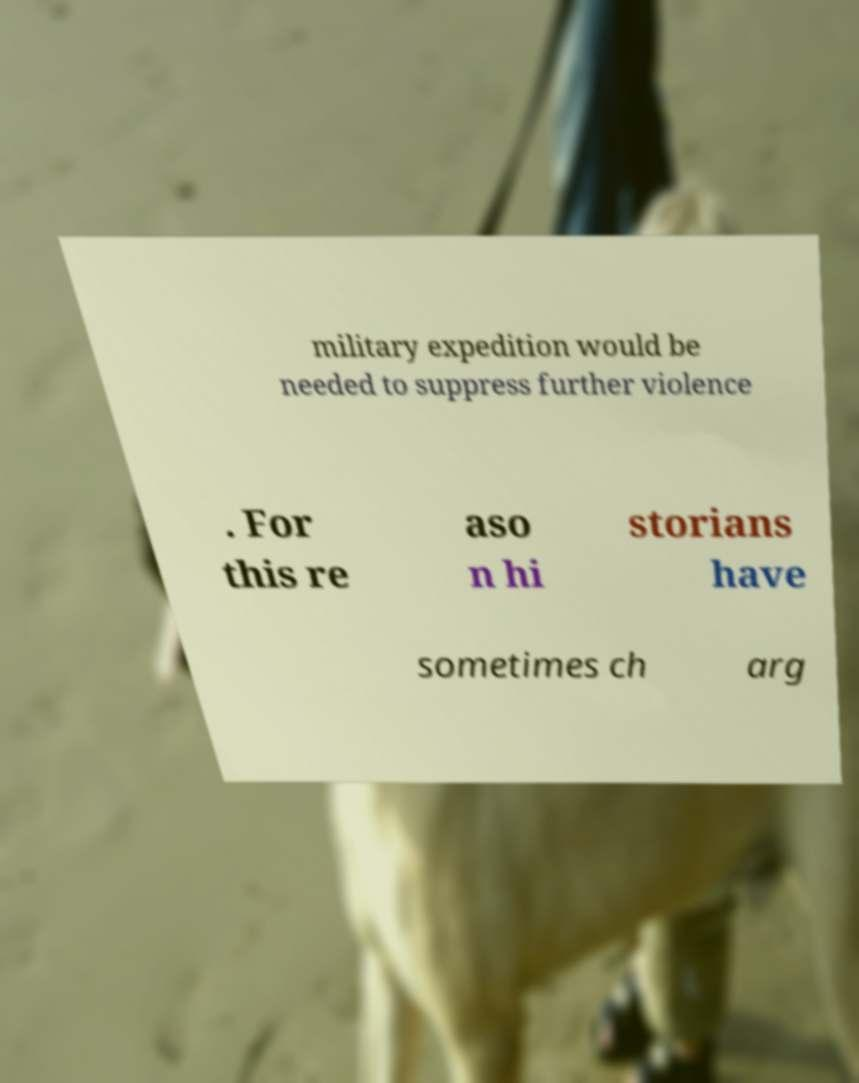I need the written content from this picture converted into text. Can you do that? military expedition would be needed to suppress further violence . For this re aso n hi storians have sometimes ch arg 